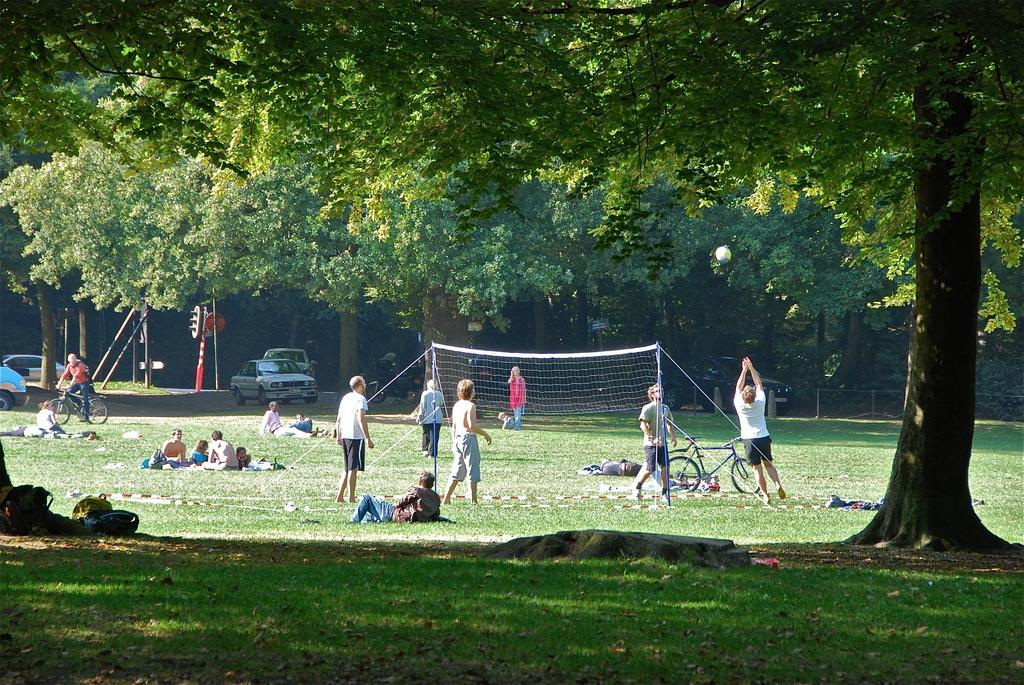Please provide a concise description of this image. In this image we can see a group of people on the ground. We can also see the net tied with the ropes, a ball, some poles, some vehicles and a person riding the bicycle. On the left side we can see some bags placed on the ground. We can also see some grass, a fence and a group of trees. 